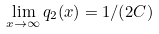Convert formula to latex. <formula><loc_0><loc_0><loc_500><loc_500>\lim _ { x { \to } \infty } { q _ { 2 } ( x ) } = 1 / ( 2 C )</formula> 